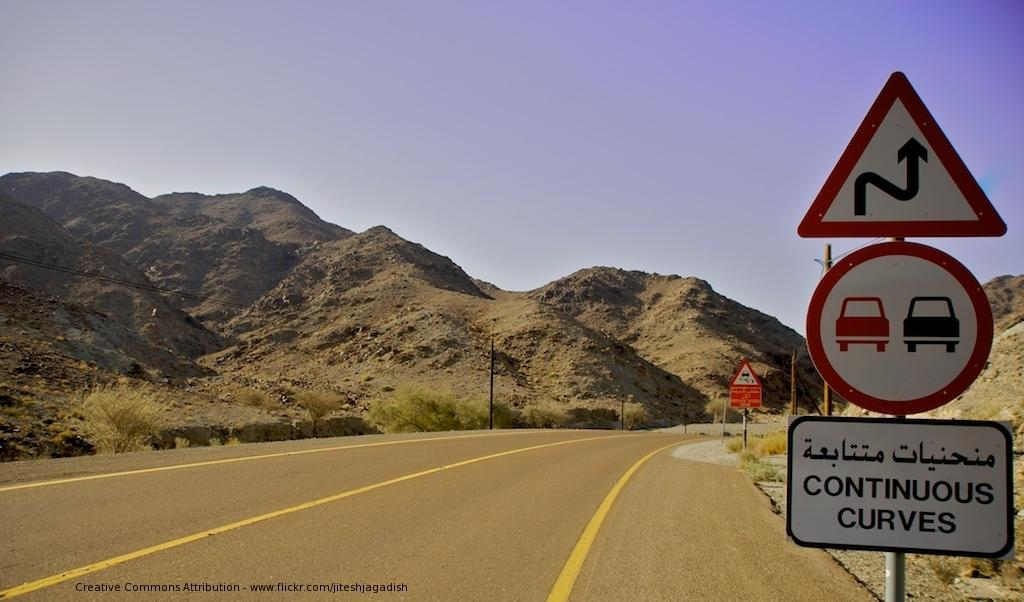<image>
Write a terse but informative summary of the picture. Road signs next to a road indicate that there are continuous curves up ahead. 